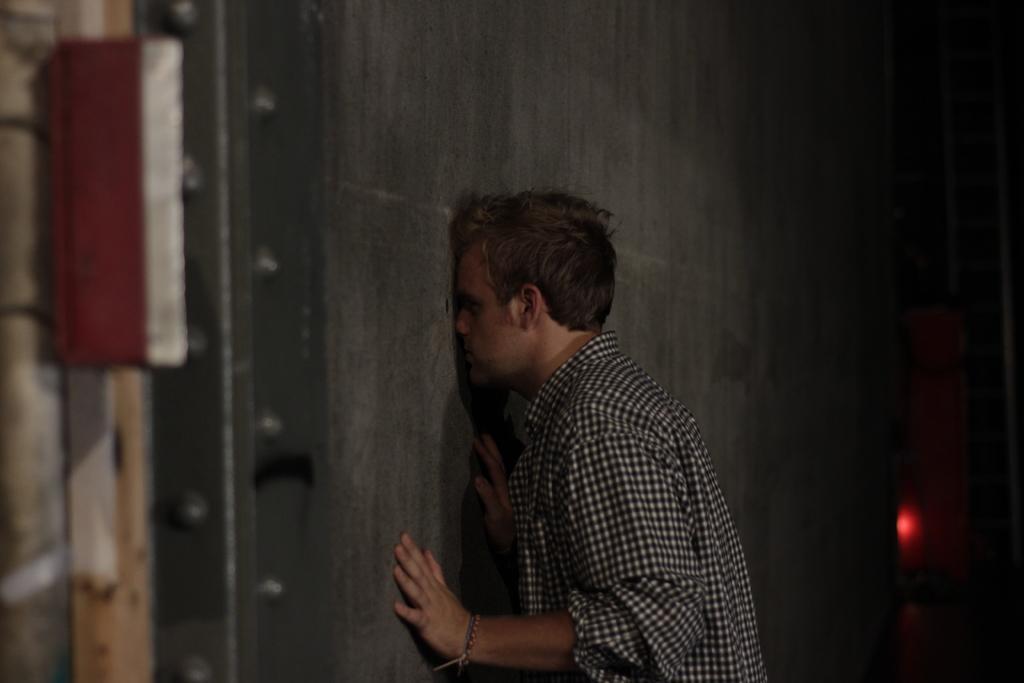In one or two sentences, can you explain what this image depicts? In this image we can see a person wearing shirt is standing near the wall. This part of the image is slightly blurred and the part of the image is dark. 